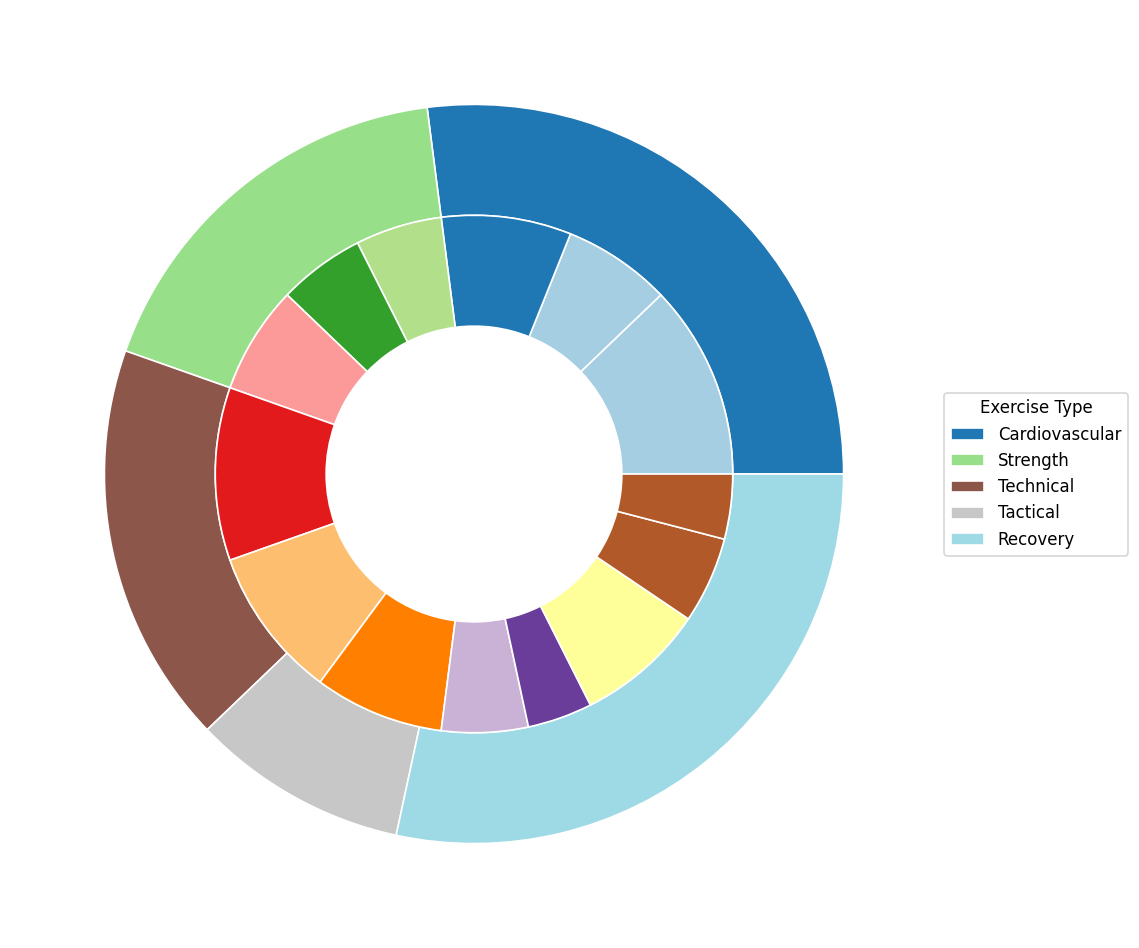Which exercise type has the highest total frequency? To find the highest total frequency, sum the frequencies of each exercise type and compare their totals. Cardiovascular: 45 + 25 + 30 = 100, Strength: 20 + 20 + 25 = 65, Technical: 40 + 35 + 30 = 105, Tactical: 20 + 15 = 35, Recovery: 30 + 20 + 15 = 65. Technical has the highest total frequency of 105.
Answer: Technical What is the combined frequency of aerobic running and interval training? Combine the frequencies of aerobic running and interval training. Aerobic Running: 45, Interval Training: 25. 45 + 25 = 70.
Answer: 70 Is the frequency of dribbling greater than the frequency of upper body strength exercises? Compare the frequencies of dribbling (40) with upper body strength exercises (20). 40 is greater than 20.
Answer: Yes How many more times is set piece practice done compared to ice baths? Subtract the frequency of ice baths from the frequency of set-piece practice. Set Piece Practice: 15, Ice Baths: 15. 15 - 15 = 0.
Answer: 0 What percentage of the total does core strength training constitute? To find the percentage, divide the frequency of core strength training by the total frequency and multiply by 100. Total frequency: 100 + 65 + 105 + 35 + 65 = 370, Core Strength: 25. (25 / 370) * 100 ≈ 6.76%
Answer: 6.76% Which exercise type has the smallest total frequency, and what is its percentage of the overall training frequency? Find the totals for each exercise type and identify the smallest. Tactical is 35. Calculate its percentage: (35 / 370) * 100 ≈ 9.46%
Answer: Tactical, 9.46% What is the average frequency of the recovery exercises? Sum the frequencies of the recovery exercises and calculate the average. Stretching: 30, Massage: 20, Ice Baths: 15. (30 + 20 + 15) / 3 = 65 / 3 ≈ 21.67
Answer: 21.67 Is passing more frequent than set-piece practice and ice baths combined? Compare the frequency of passing (35) with the combined frequency of set-piece practice and ice baths (15 + 15). 35 is greater than 30.
Answer: Yes What is the visual outer color representing the tactical exercise type in the pie chart? The outer color representing the tactical exercise type must be identified by comparing to a typical color pattern. Based on common color schemes, tactical exercises might be in shades typically reserved for latter items on the color palette.
Answer: Varies (e.g., purple based on typical tab20/Paired mapping) How much more frequent is cardiovascular exercise than recovery exercises? Compare the total frequencies of cardiovascular (100) and recovery (65) exercises. 100 - 65 = 35.
Answer: 35 